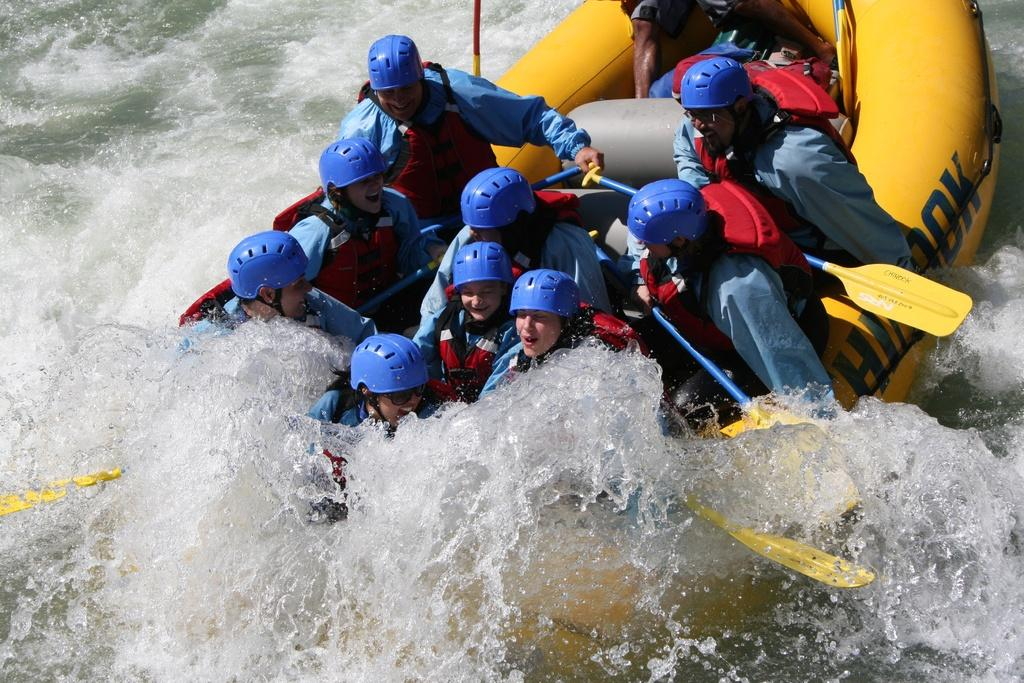How many people are in the image? There is a group of persons in the image. What are the persons doing in the image? The persons are sitting on a surf boat and rowing it. Where is the boat located in the image? The boat is in the water. What type of beam is holding up the boat in the image? There is no beam present in the image; the boat is floating on the water. What is the weight of the persons in the boat? The weight of the persons in the boat cannot be determined from the image alone. 